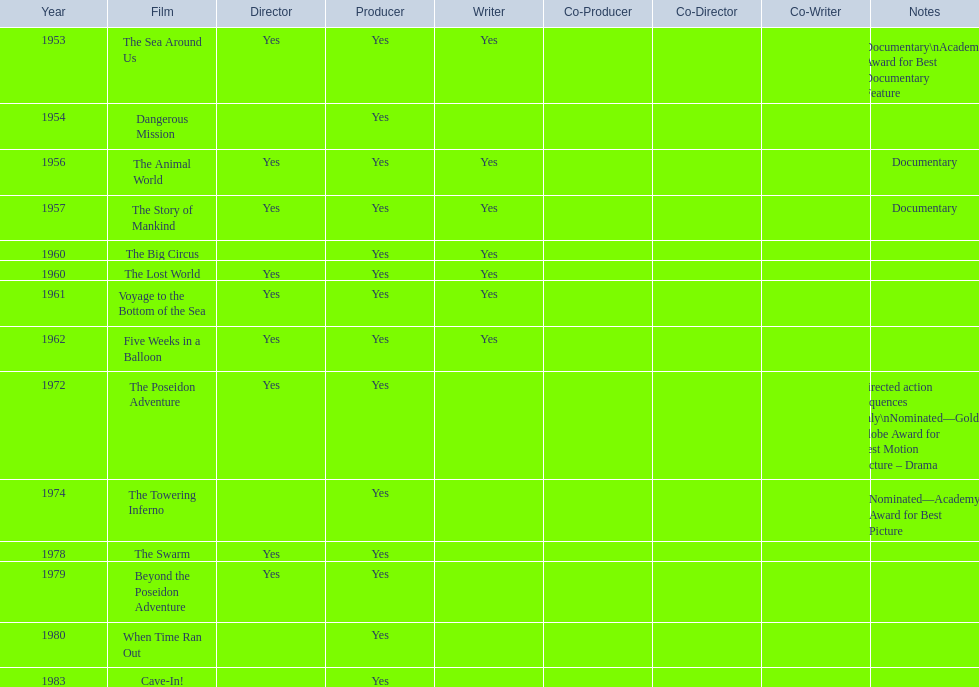How many films did irwin allen direct, produce and write? 6. 